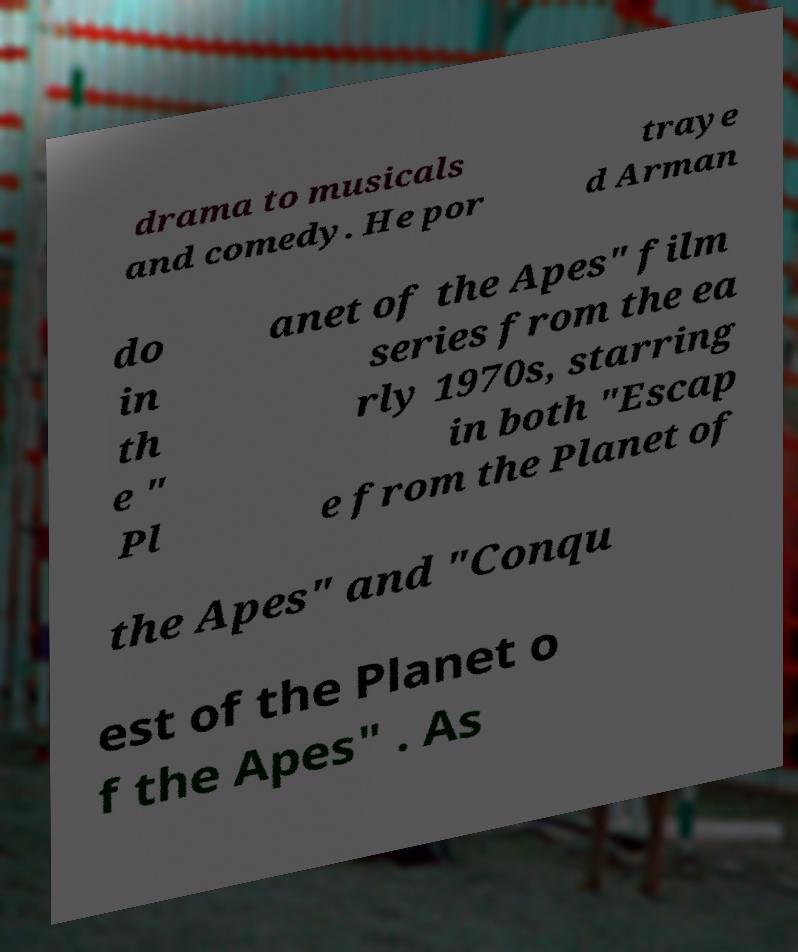For documentation purposes, I need the text within this image transcribed. Could you provide that? drama to musicals and comedy. He por traye d Arman do in th e " Pl anet of the Apes" film series from the ea rly 1970s, starring in both "Escap e from the Planet of the Apes" and "Conqu est of the Planet o f the Apes" . As 